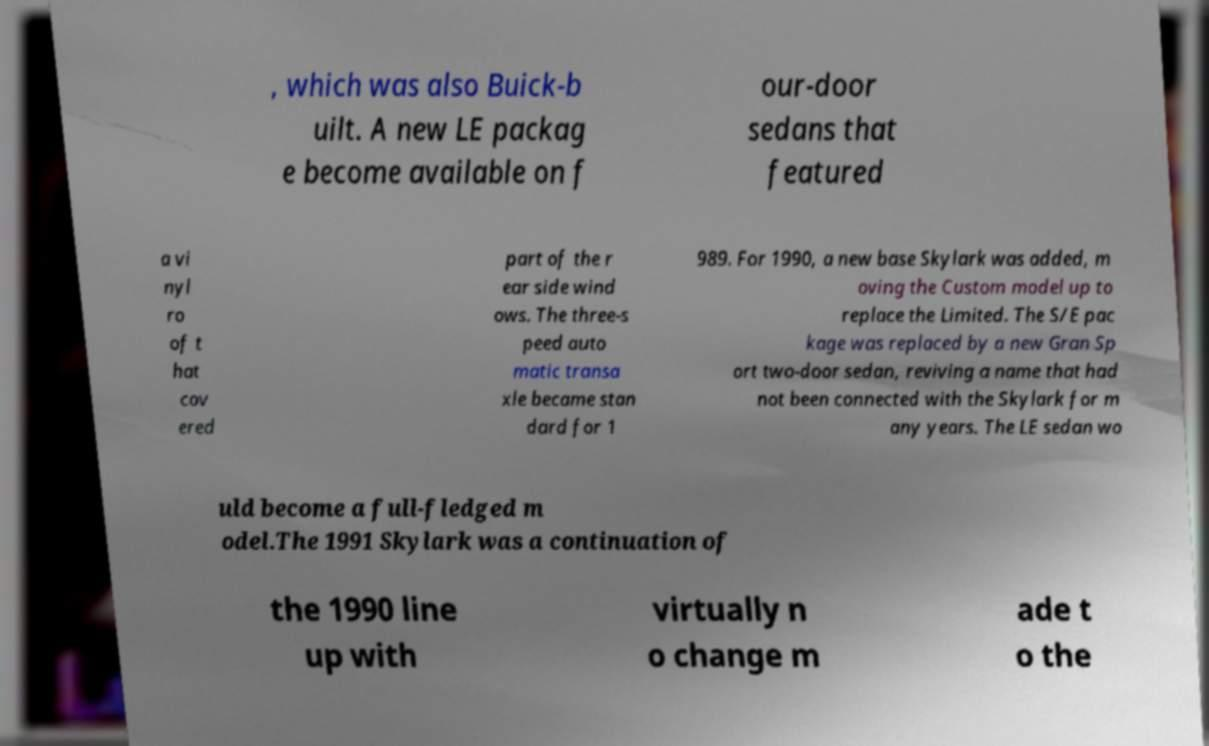Can you accurately transcribe the text from the provided image for me? , which was also Buick-b uilt. A new LE packag e become available on f our-door sedans that featured a vi nyl ro of t hat cov ered part of the r ear side wind ows. The three-s peed auto matic transa xle became stan dard for 1 989. For 1990, a new base Skylark was added, m oving the Custom model up to replace the Limited. The S/E pac kage was replaced by a new Gran Sp ort two-door sedan, reviving a name that had not been connected with the Skylark for m any years. The LE sedan wo uld become a full-fledged m odel.The 1991 Skylark was a continuation of the 1990 line up with virtually n o change m ade t o the 